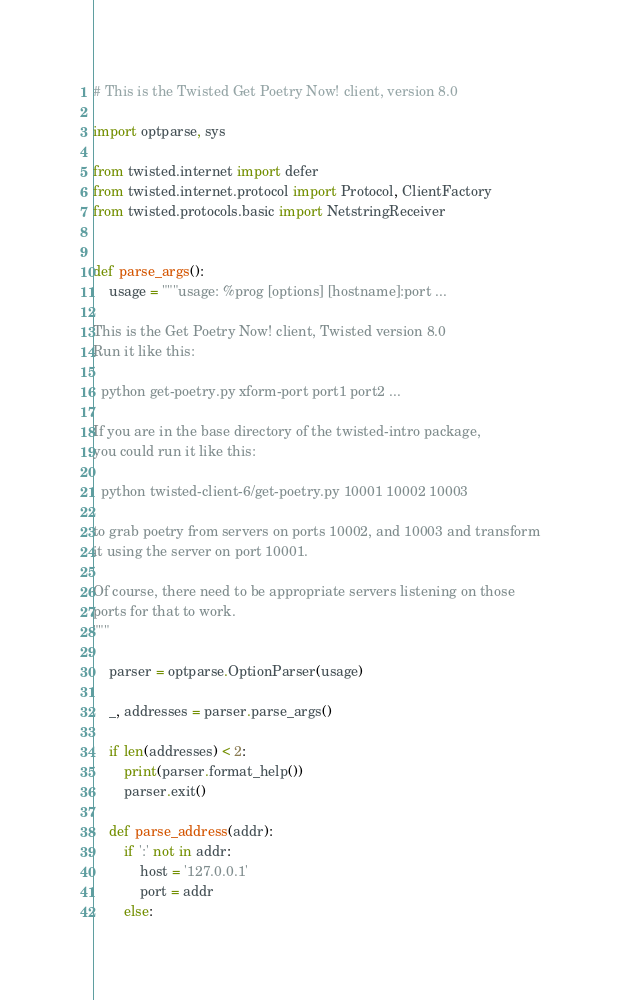Convert code to text. <code><loc_0><loc_0><loc_500><loc_500><_Python_># This is the Twisted Get Poetry Now! client, version 8.0

import optparse, sys

from twisted.internet import defer
from twisted.internet.protocol import Protocol, ClientFactory
from twisted.protocols.basic import NetstringReceiver


def parse_args():
    usage = """usage: %prog [options] [hostname]:port ...

This is the Get Poetry Now! client, Twisted version 8.0
Run it like this:

  python get-poetry.py xform-port port1 port2 ...

If you are in the base directory of the twisted-intro package,
you could run it like this:

  python twisted-client-6/get-poetry.py 10001 10002 10003

to grab poetry from servers on ports 10002, and 10003 and transform
it using the server on port 10001.

Of course, there need to be appropriate servers listening on those
ports for that to work.
"""

    parser = optparse.OptionParser(usage)

    _, addresses = parser.parse_args()

    if len(addresses) < 2:
        print(parser.format_help())
        parser.exit()

    def parse_address(addr):
        if ':' not in addr:
            host = '127.0.0.1'
            port = addr
        else:</code> 